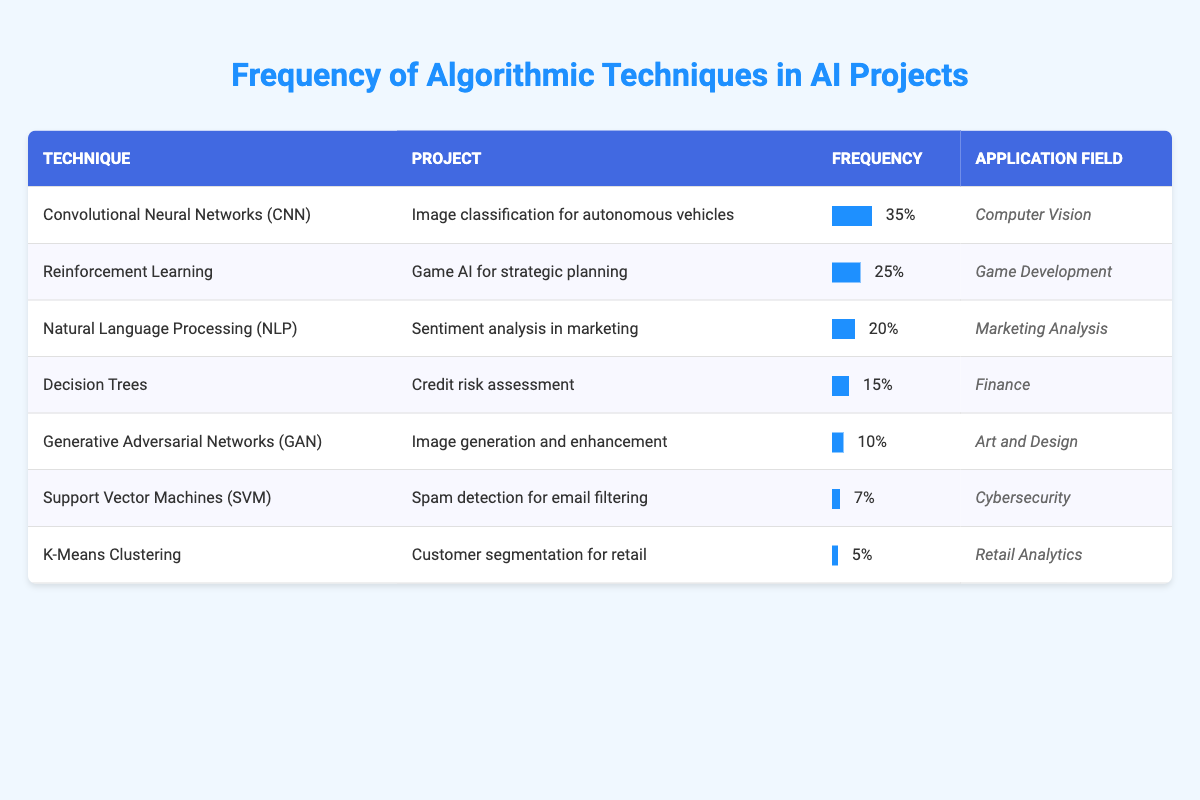What is the technique with the highest frequency in the table? By scanning the 'Frequency' column, I identify that 'Convolutional Neural Networks (CNN)' has the highest value at 35.
Answer: Convolutional Neural Networks (CNN) Which application field has the least frequency in the projects listed? Looking through the 'Application Field' column, 'Retail Analytics' is associated with 'K-Means Clustering', which has the least frequency of 5.
Answer: Retail Analytics How many more projects utilize 'Reinforcement Learning' compared to 'K-Means Clustering'? 'Reinforcement Learning' has a frequency of 25, while 'K-Means Clustering' has a frequency of 5. Subtracting these gives 25 - 5 = 20.
Answer: 20 Is Natural Language Processing (NLP) used more frequently than Decision Trees? Natural Language Processing (NLP) has a frequency of 20, and Decision Trees have a frequency of 15. Since 20 is greater than 15, the statement is true.
Answer: Yes What is the combined frequency of the top three techniques? The top three techniques are 'Convolutional Neural Networks (CNN)' with 35, 'Reinforcement Learning' with 25, and 'Natural Language Processing (NLP)' with 20. Adding these gives 35 + 25 + 20 = 80.
Answer: 80 